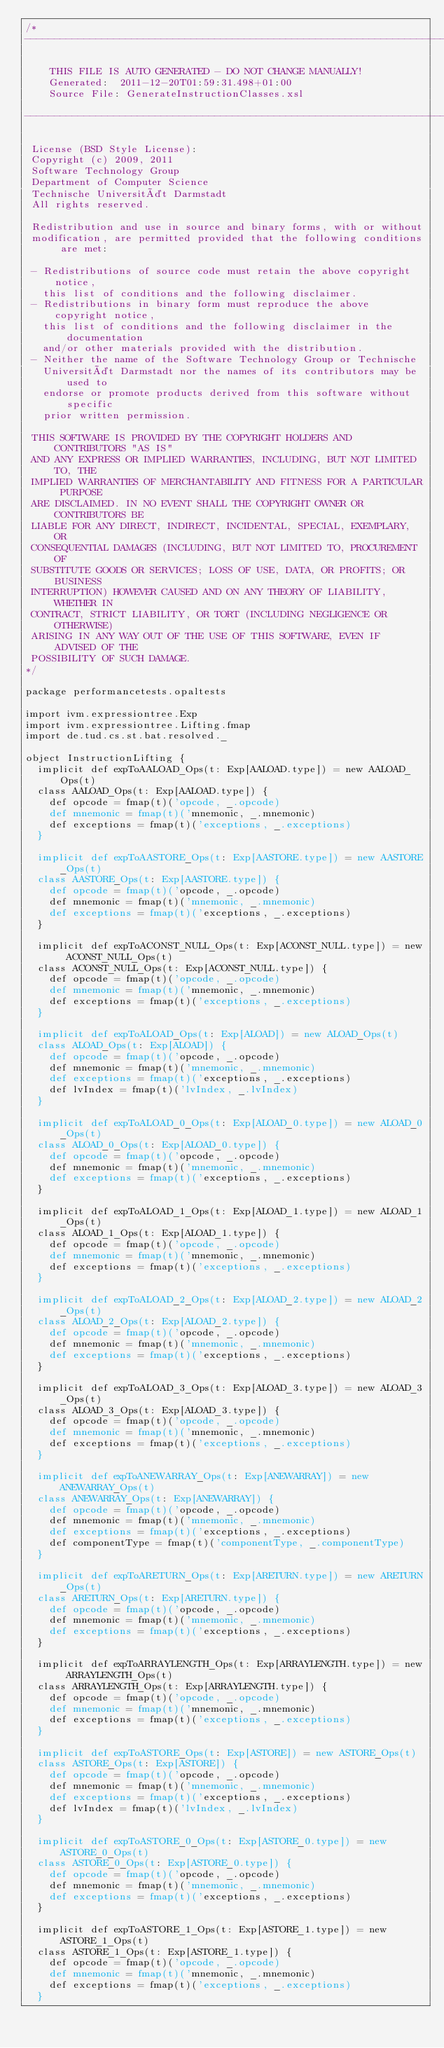Convert code to text. <code><loc_0><loc_0><loc_500><loc_500><_Scala_>/*
--------------------------------------------------------------------------

		THIS FILE IS AUTO GENERATED - DO NOT CHANGE MANUALLY!
		Generated:  2011-12-20T01:59:31.498+01:00
		Source File: GenerateInstructionClasses.xsl

--------------------------------------------------------------------------

 License (BSD Style License):
 Copyright (c) 2009, 2011
 Software Technology Group
 Department of Computer Science
 Technische Universität Darmstadt
 All rights reserved.

 Redistribution and use in source and binary forms, with or without
 modification, are permitted provided that the following conditions are met:

 - Redistributions of source code must retain the above copyright notice,
   this list of conditions and the following disclaimer.
 - Redistributions in binary form must reproduce the above copyright notice,
   this list of conditions and the following disclaimer in the documentation
   and/or other materials provided with the distribution.
 - Neither the name of the Software Technology Group or Technische
   Universität Darmstadt nor the names of its contributors may be used to
   endorse or promote products derived from this software without specific
   prior written permission.

 THIS SOFTWARE IS PROVIDED BY THE COPYRIGHT HOLDERS AND CONTRIBUTORS "AS IS"
 AND ANY EXPRESS OR IMPLIED WARRANTIES, INCLUDING, BUT NOT LIMITED TO, THE
 IMPLIED WARRANTIES OF MERCHANTABILITY AND FITNESS FOR A PARTICULAR PURPOSE
 ARE DISCLAIMED. IN NO EVENT SHALL THE COPYRIGHT OWNER OR CONTRIBUTORS BE
 LIABLE FOR ANY DIRECT, INDIRECT, INCIDENTAL, SPECIAL, EXEMPLARY, OR
 CONSEQUENTIAL DAMAGES (INCLUDING, BUT NOT LIMITED TO, PROCUREMENT OF
 SUBSTITUTE GOODS OR SERVICES; LOSS OF USE, DATA, OR PROFITS; OR BUSINESS
 INTERRUPTION) HOWEVER CAUSED AND ON ANY THEORY OF LIABILITY, WHETHER IN
 CONTRACT, STRICT LIABILITY, OR TORT (INCLUDING NEGLIGENCE OR OTHERWISE)
 ARISING IN ANY WAY OUT OF THE USE OF THIS SOFTWARE, EVEN IF ADVISED OF THE
 POSSIBILITY OF SUCH DAMAGE.
*/

package performancetests.opaltests

import ivm.expressiontree.Exp
import ivm.expressiontree.Lifting.fmap
import de.tud.cs.st.bat.resolved._

object InstructionLifting {
	implicit def expToAALOAD_Ops(t: Exp[AALOAD.type]) = new AALOAD_Ops(t)
	class AALOAD_Ops(t: Exp[AALOAD.type]) {
		def opcode = fmap(t)('opcode, _.opcode)
		def mnemonic = fmap(t)('mnemonic, _.mnemonic)
		def exceptions = fmap(t)('exceptions, _.exceptions)
	}

	implicit def expToAASTORE_Ops(t: Exp[AASTORE.type]) = new AASTORE_Ops(t)
	class AASTORE_Ops(t: Exp[AASTORE.type]) {
		def opcode = fmap(t)('opcode, _.opcode)
		def mnemonic = fmap(t)('mnemonic, _.mnemonic)
		def exceptions = fmap(t)('exceptions, _.exceptions)
	}

	implicit def expToACONST_NULL_Ops(t: Exp[ACONST_NULL.type]) = new ACONST_NULL_Ops(t)
	class ACONST_NULL_Ops(t: Exp[ACONST_NULL.type]) {
		def opcode = fmap(t)('opcode, _.opcode)
		def mnemonic = fmap(t)('mnemonic, _.mnemonic)
		def exceptions = fmap(t)('exceptions, _.exceptions)
	}

	implicit def expToALOAD_Ops(t: Exp[ALOAD]) = new ALOAD_Ops(t)
	class ALOAD_Ops(t: Exp[ALOAD]) {
		def opcode = fmap(t)('opcode, _.opcode)
		def mnemonic = fmap(t)('mnemonic, _.mnemonic)
		def exceptions = fmap(t)('exceptions, _.exceptions)
		def lvIndex = fmap(t)('lvIndex, _.lvIndex)
	}

	implicit def expToALOAD_0_Ops(t: Exp[ALOAD_0.type]) = new ALOAD_0_Ops(t)
	class ALOAD_0_Ops(t: Exp[ALOAD_0.type]) {
		def opcode = fmap(t)('opcode, _.opcode)
		def mnemonic = fmap(t)('mnemonic, _.mnemonic)
		def exceptions = fmap(t)('exceptions, _.exceptions)
	}

	implicit def expToALOAD_1_Ops(t: Exp[ALOAD_1.type]) = new ALOAD_1_Ops(t)
	class ALOAD_1_Ops(t: Exp[ALOAD_1.type]) {
		def opcode = fmap(t)('opcode, _.opcode)
		def mnemonic = fmap(t)('mnemonic, _.mnemonic)
		def exceptions = fmap(t)('exceptions, _.exceptions)
	}

	implicit def expToALOAD_2_Ops(t: Exp[ALOAD_2.type]) = new ALOAD_2_Ops(t)
	class ALOAD_2_Ops(t: Exp[ALOAD_2.type]) {
		def opcode = fmap(t)('opcode, _.opcode)
		def mnemonic = fmap(t)('mnemonic, _.mnemonic)
		def exceptions = fmap(t)('exceptions, _.exceptions)
	}

	implicit def expToALOAD_3_Ops(t: Exp[ALOAD_3.type]) = new ALOAD_3_Ops(t)
	class ALOAD_3_Ops(t: Exp[ALOAD_3.type]) {
		def opcode = fmap(t)('opcode, _.opcode)
		def mnemonic = fmap(t)('mnemonic, _.mnemonic)
		def exceptions = fmap(t)('exceptions, _.exceptions)
	}

	implicit def expToANEWARRAY_Ops(t: Exp[ANEWARRAY]) = new ANEWARRAY_Ops(t)
	class ANEWARRAY_Ops(t: Exp[ANEWARRAY]) {
		def opcode = fmap(t)('opcode, _.opcode)
		def mnemonic = fmap(t)('mnemonic, _.mnemonic)
		def exceptions = fmap(t)('exceptions, _.exceptions)
		def componentType = fmap(t)('componentType, _.componentType)
	}

	implicit def expToARETURN_Ops(t: Exp[ARETURN.type]) = new ARETURN_Ops(t)
	class ARETURN_Ops(t: Exp[ARETURN.type]) {
		def opcode = fmap(t)('opcode, _.opcode)
		def mnemonic = fmap(t)('mnemonic, _.mnemonic)
		def exceptions = fmap(t)('exceptions, _.exceptions)
	}

	implicit def expToARRAYLENGTH_Ops(t: Exp[ARRAYLENGTH.type]) = new ARRAYLENGTH_Ops(t)
	class ARRAYLENGTH_Ops(t: Exp[ARRAYLENGTH.type]) {
		def opcode = fmap(t)('opcode, _.opcode)
		def mnemonic = fmap(t)('mnemonic, _.mnemonic)
		def exceptions = fmap(t)('exceptions, _.exceptions)
	}

	implicit def expToASTORE_Ops(t: Exp[ASTORE]) = new ASTORE_Ops(t)
	class ASTORE_Ops(t: Exp[ASTORE]) {
		def opcode = fmap(t)('opcode, _.opcode)
		def mnemonic = fmap(t)('mnemonic, _.mnemonic)
		def exceptions = fmap(t)('exceptions, _.exceptions)
		def lvIndex = fmap(t)('lvIndex, _.lvIndex)
	}

	implicit def expToASTORE_0_Ops(t: Exp[ASTORE_0.type]) = new ASTORE_0_Ops(t)
	class ASTORE_0_Ops(t: Exp[ASTORE_0.type]) {
		def opcode = fmap(t)('opcode, _.opcode)
		def mnemonic = fmap(t)('mnemonic, _.mnemonic)
		def exceptions = fmap(t)('exceptions, _.exceptions)
	}

	implicit def expToASTORE_1_Ops(t: Exp[ASTORE_1.type]) = new ASTORE_1_Ops(t)
	class ASTORE_1_Ops(t: Exp[ASTORE_1.type]) {
		def opcode = fmap(t)('opcode, _.opcode)
		def mnemonic = fmap(t)('mnemonic, _.mnemonic)
		def exceptions = fmap(t)('exceptions, _.exceptions)
	}
</code> 